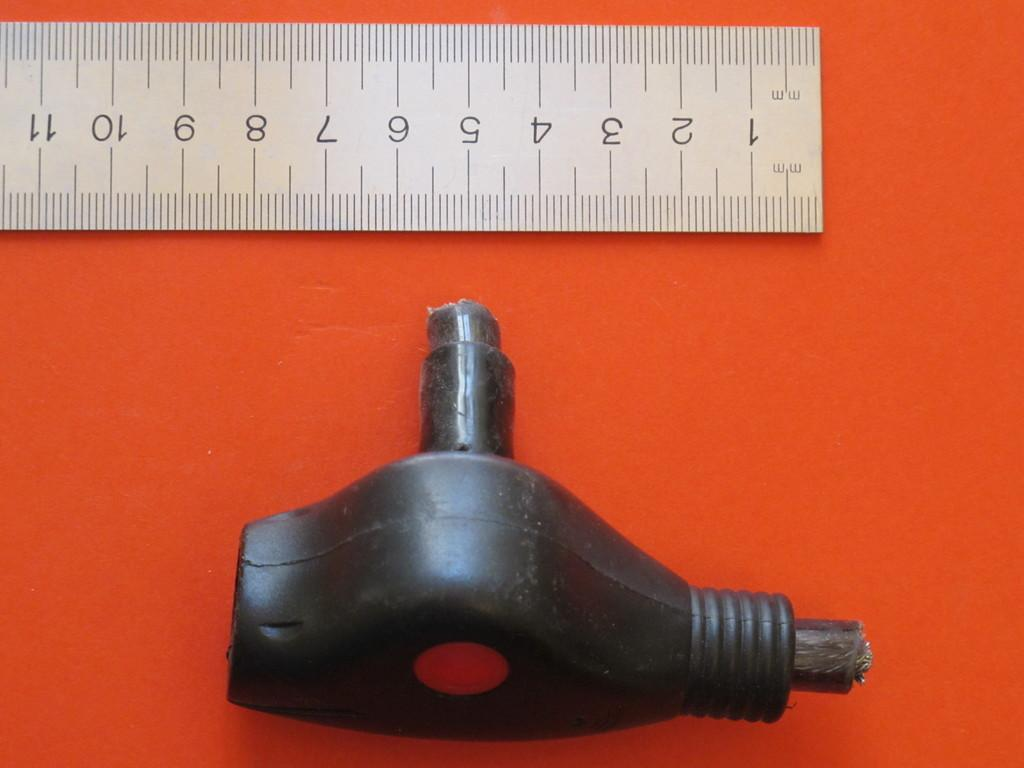<image>
Describe the image concisely. A ruler showing the numbers 1 through 11 with some sort of tool next to it. 